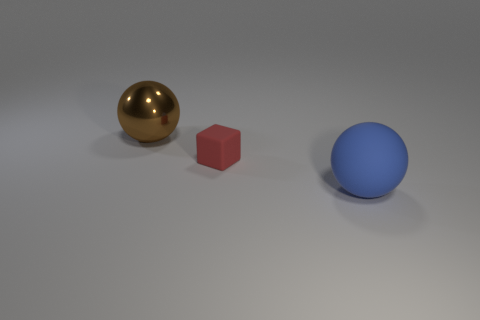Is the size of the metal object the same as the blue thing?
Make the answer very short. Yes. How many objects are large things to the right of the red block or rubber things behind the large blue matte ball?
Ensure brevity in your answer.  2. Are there the same number of large blue objects that are on the left side of the blue matte ball and tiny things in front of the big brown metallic thing?
Ensure brevity in your answer.  No. Are there more big objects in front of the large shiny thing than purple matte spheres?
Offer a terse response. Yes. How many objects are either large spheres in front of the large brown metallic object or blue balls?
Offer a very short reply. 1. How many other small gray cubes have the same material as the block?
Provide a short and direct response. 0. Is there another big rubber thing that has the same shape as the brown thing?
Keep it short and to the point. Yes. What is the shape of the brown object that is the same size as the blue rubber ball?
Give a very brief answer. Sphere. How many big things are right of the large ball that is behind the tiny red matte block?
Offer a terse response. 1. What is the size of the object that is to the left of the large blue sphere and to the right of the metal object?
Your response must be concise. Small. 